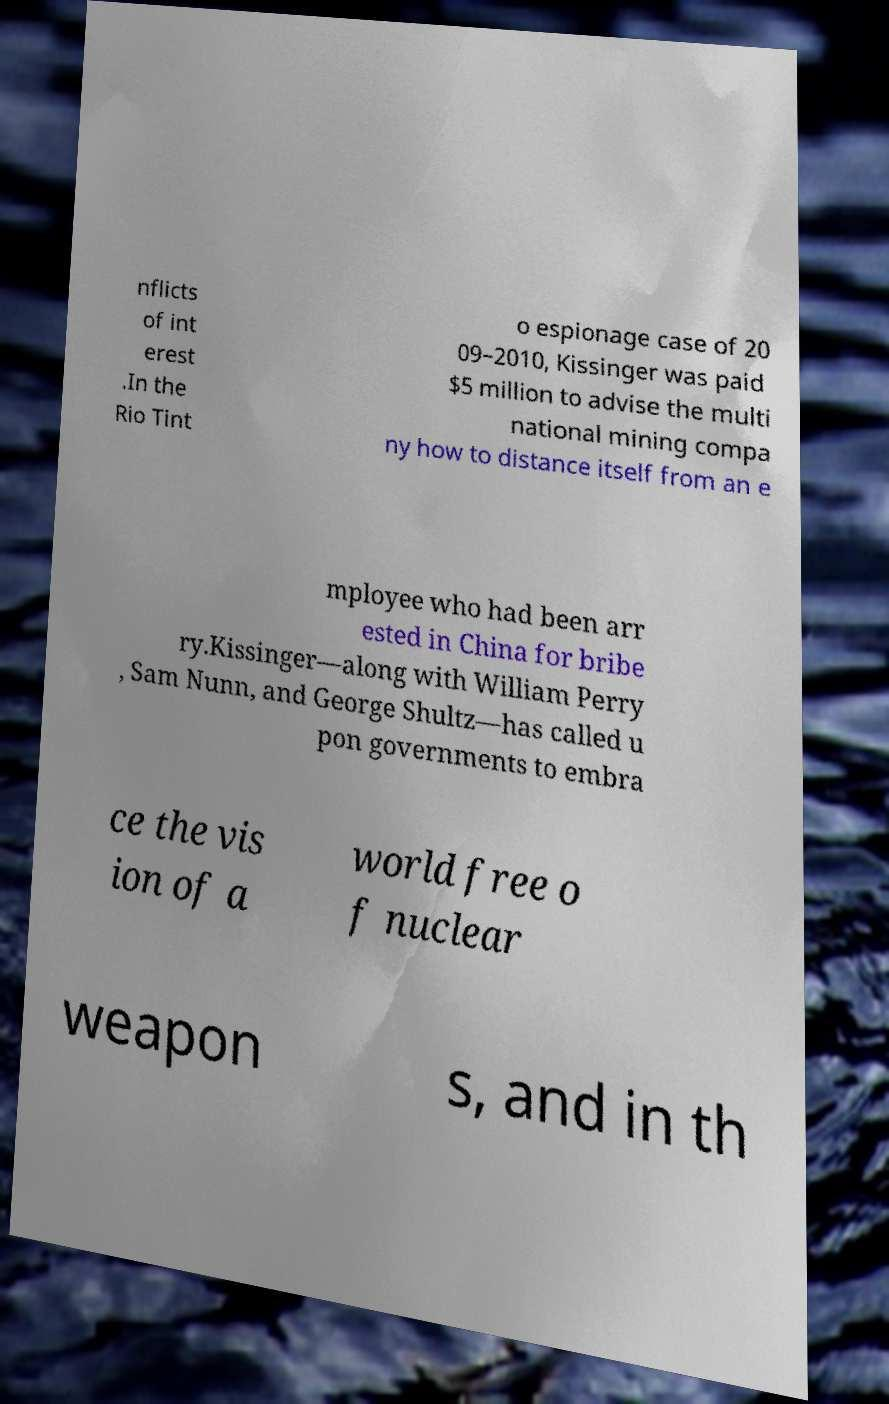Could you assist in decoding the text presented in this image and type it out clearly? nflicts of int erest .In the Rio Tint o espionage case of 20 09–2010, Kissinger was paid $5 million to advise the multi national mining compa ny how to distance itself from an e mployee who had been arr ested in China for bribe ry.Kissinger—along with William Perry , Sam Nunn, and George Shultz—has called u pon governments to embra ce the vis ion of a world free o f nuclear weapon s, and in th 